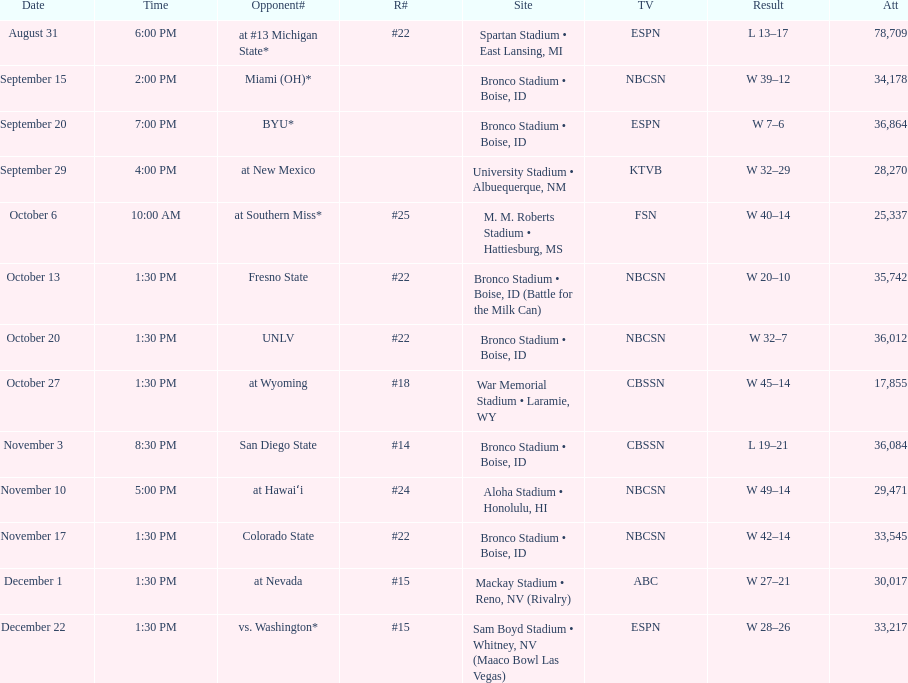What was the most consecutive wins for the team shown in the season? 7. 